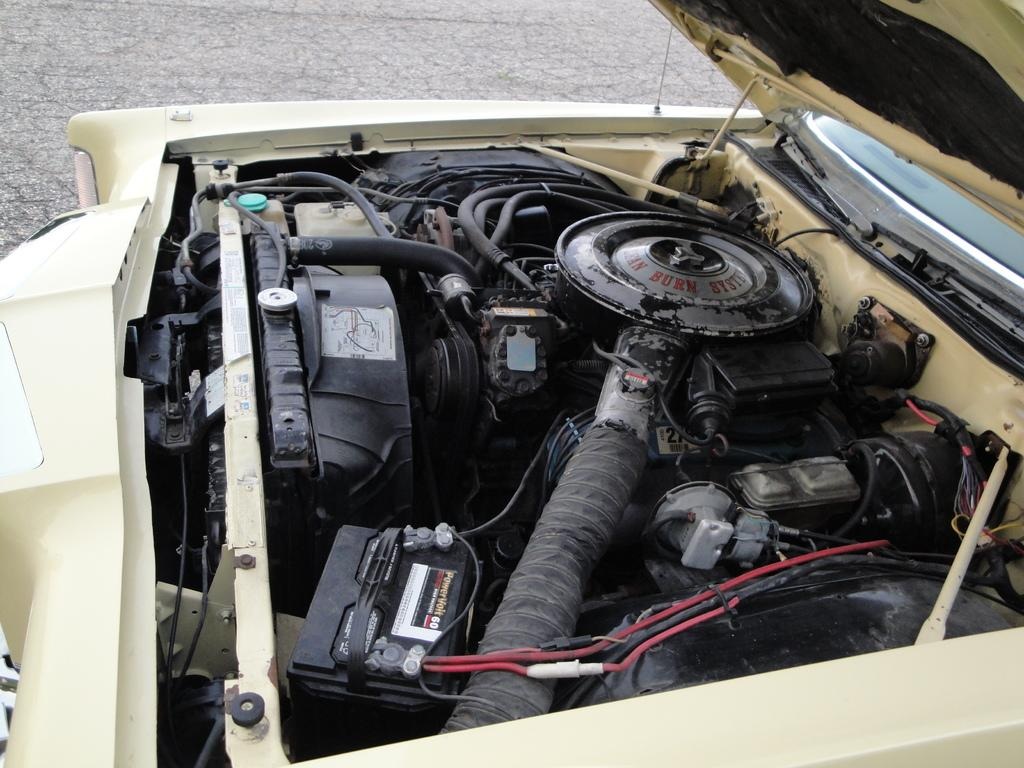What is the main subject of the image? The main subject of the image is a vehicle engine. Can you describe the color of the vehicle? The vehicle is cream-colored. What color is the background of the image? The background of the image is gray. What type of skin condition can be seen on the vehicle in the image? There is no skin condition present on the vehicle in the image, as vehicles do not have skin. How many screws are visible on the vehicle in the image? The number of screws cannot be determined from the image, as it only shows the vehicle engine and not the entire vehicle. 